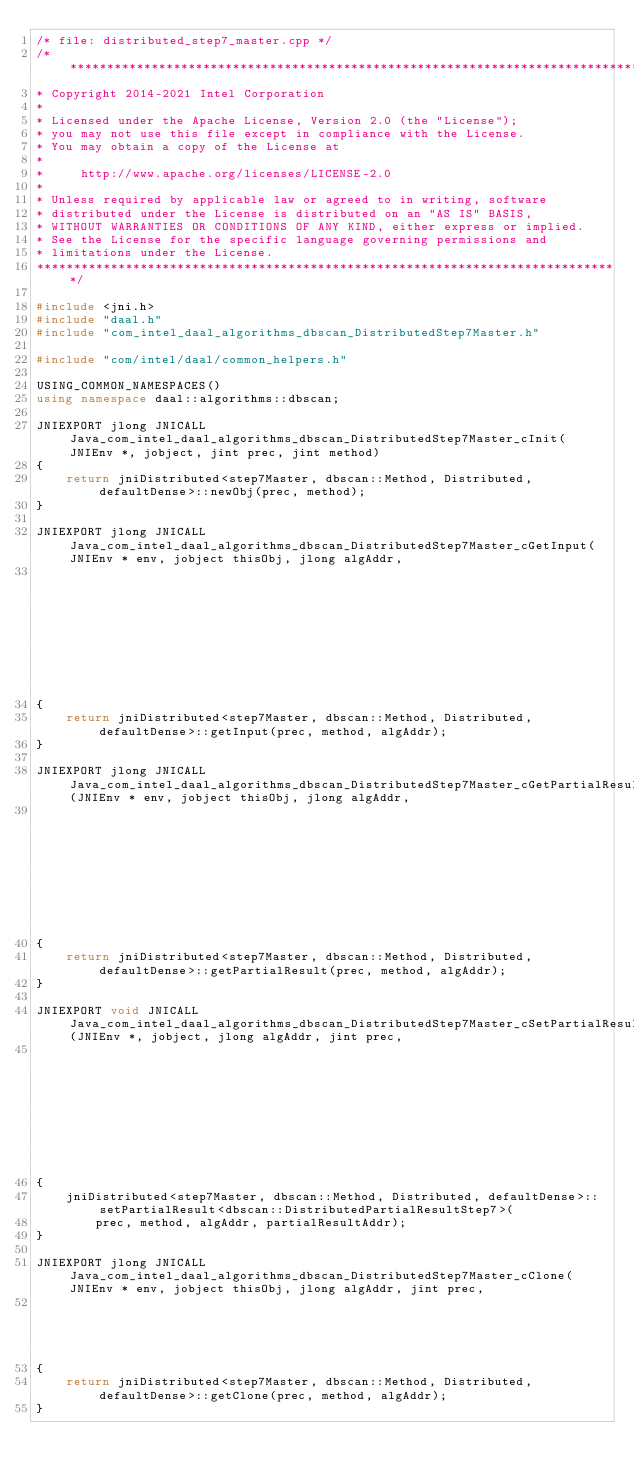Convert code to text. <code><loc_0><loc_0><loc_500><loc_500><_C++_>/* file: distributed_step7_master.cpp */
/*******************************************************************************
* Copyright 2014-2021 Intel Corporation
*
* Licensed under the Apache License, Version 2.0 (the "License");
* you may not use this file except in compliance with the License.
* You may obtain a copy of the License at
*
*     http://www.apache.org/licenses/LICENSE-2.0
*
* Unless required by applicable law or agreed to in writing, software
* distributed under the License is distributed on an "AS IS" BASIS,
* WITHOUT WARRANTIES OR CONDITIONS OF ANY KIND, either express or implied.
* See the License for the specific language governing permissions and
* limitations under the License.
*******************************************************************************/

#include <jni.h>
#include "daal.h"
#include "com_intel_daal_algorithms_dbscan_DistributedStep7Master.h"

#include "com/intel/daal/common_helpers.h"

USING_COMMON_NAMESPACES()
using namespace daal::algorithms::dbscan;

JNIEXPORT jlong JNICALL Java_com_intel_daal_algorithms_dbscan_DistributedStep7Master_cInit(JNIEnv *, jobject, jint prec, jint method)
{
    return jniDistributed<step7Master, dbscan::Method, Distributed, defaultDense>::newObj(prec, method);
}

JNIEXPORT jlong JNICALL Java_com_intel_daal_algorithms_dbscan_DistributedStep7Master_cGetInput(JNIEnv * env, jobject thisObj, jlong algAddr,
                                                                                               jint prec, jint method)
{
    return jniDistributed<step7Master, dbscan::Method, Distributed, defaultDense>::getInput(prec, method, algAddr);
}

JNIEXPORT jlong JNICALL Java_com_intel_daal_algorithms_dbscan_DistributedStep7Master_cGetPartialResult(JNIEnv * env, jobject thisObj, jlong algAddr,
                                                                                                       jint prec, jint method)
{
    return jniDistributed<step7Master, dbscan::Method, Distributed, defaultDense>::getPartialResult(prec, method, algAddr);
}

JNIEXPORT void JNICALL Java_com_intel_daal_algorithms_dbscan_DistributedStep7Master_cSetPartialResult(JNIEnv *, jobject, jlong algAddr, jint prec,
                                                                                                      jint method, jlong partialResultAddr)
{
    jniDistributed<step7Master, dbscan::Method, Distributed, defaultDense>::setPartialResult<dbscan::DistributedPartialResultStep7>(
        prec, method, algAddr, partialResultAddr);
}

JNIEXPORT jlong JNICALL Java_com_intel_daal_algorithms_dbscan_DistributedStep7Master_cClone(JNIEnv * env, jobject thisObj, jlong algAddr, jint prec,
                                                                                            jint method)
{
    return jniDistributed<step7Master, dbscan::Method, Distributed, defaultDense>::getClone(prec, method, algAddr);
}
</code> 